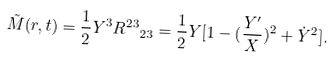<formula> <loc_0><loc_0><loc_500><loc_500>\tilde { M } ( r , t ) = \frac { 1 } { 2 } Y ^ { 3 } { R ^ { 2 3 } } _ { 2 3 } = \frac { 1 } { 2 } Y [ 1 - ( \frac { Y ^ { \prime } } { X } ) ^ { 2 } + \dot { Y } ^ { 2 } ] .</formula> 